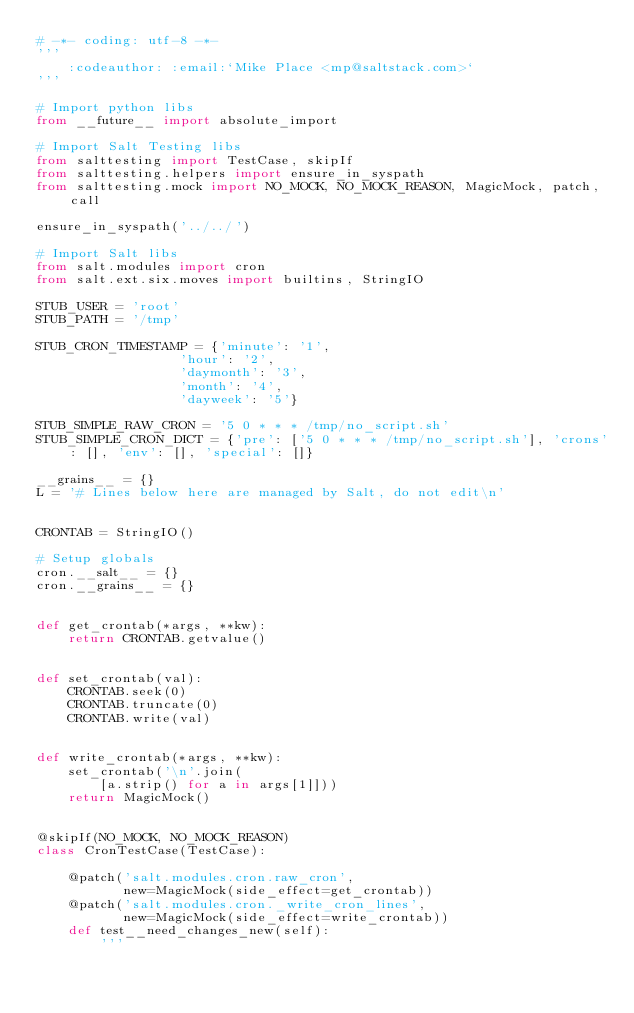<code> <loc_0><loc_0><loc_500><loc_500><_Python_># -*- coding: utf-8 -*-
'''
    :codeauthor: :email:`Mike Place <mp@saltstack.com>`
'''

# Import python libs
from __future__ import absolute_import

# Import Salt Testing libs
from salttesting import TestCase, skipIf
from salttesting.helpers import ensure_in_syspath
from salttesting.mock import NO_MOCK, NO_MOCK_REASON, MagicMock, patch, call

ensure_in_syspath('../../')

# Import Salt libs
from salt.modules import cron
from salt.ext.six.moves import builtins, StringIO

STUB_USER = 'root'
STUB_PATH = '/tmp'

STUB_CRON_TIMESTAMP = {'minute': '1',
                  'hour': '2',
                  'daymonth': '3',
                  'month': '4',
                  'dayweek': '5'}

STUB_SIMPLE_RAW_CRON = '5 0 * * * /tmp/no_script.sh'
STUB_SIMPLE_CRON_DICT = {'pre': ['5 0 * * * /tmp/no_script.sh'], 'crons': [], 'env': [], 'special': []}

__grains__ = {}
L = '# Lines below here are managed by Salt, do not edit\n'


CRONTAB = StringIO()

# Setup globals
cron.__salt__ = {}
cron.__grains__ = {}


def get_crontab(*args, **kw):
    return CRONTAB.getvalue()


def set_crontab(val):
    CRONTAB.seek(0)
    CRONTAB.truncate(0)
    CRONTAB.write(val)


def write_crontab(*args, **kw):
    set_crontab('\n'.join(
        [a.strip() for a in args[1]]))
    return MagicMock()


@skipIf(NO_MOCK, NO_MOCK_REASON)
class CronTestCase(TestCase):

    @patch('salt.modules.cron.raw_cron',
           new=MagicMock(side_effect=get_crontab))
    @patch('salt.modules.cron._write_cron_lines',
           new=MagicMock(side_effect=write_crontab))
    def test__need_changes_new(self):
        '''</code> 